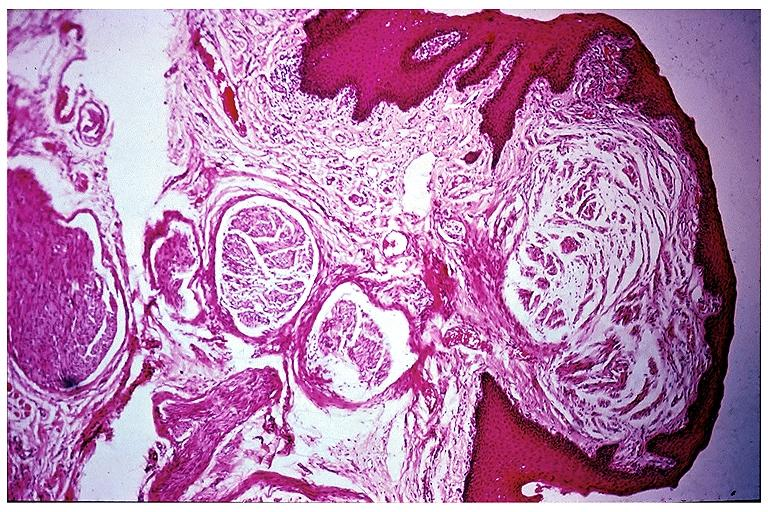does supernumerary digits show multiple endocrine neoplasia type ii b-neuroma?
Answer the question using a single word or phrase. No 